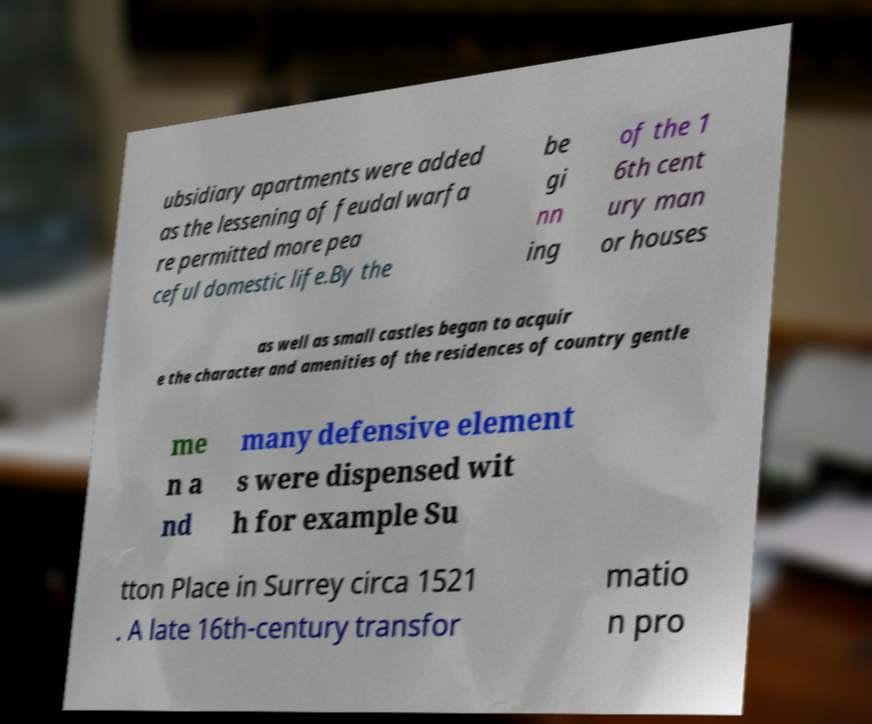What messages or text are displayed in this image? I need them in a readable, typed format. ubsidiary apartments were added as the lessening of feudal warfa re permitted more pea ceful domestic life.By the be gi nn ing of the 1 6th cent ury man or houses as well as small castles began to acquir e the character and amenities of the residences of country gentle me n a nd many defensive element s were dispensed wit h for example Su tton Place in Surrey circa 1521 . A late 16th-century transfor matio n pro 